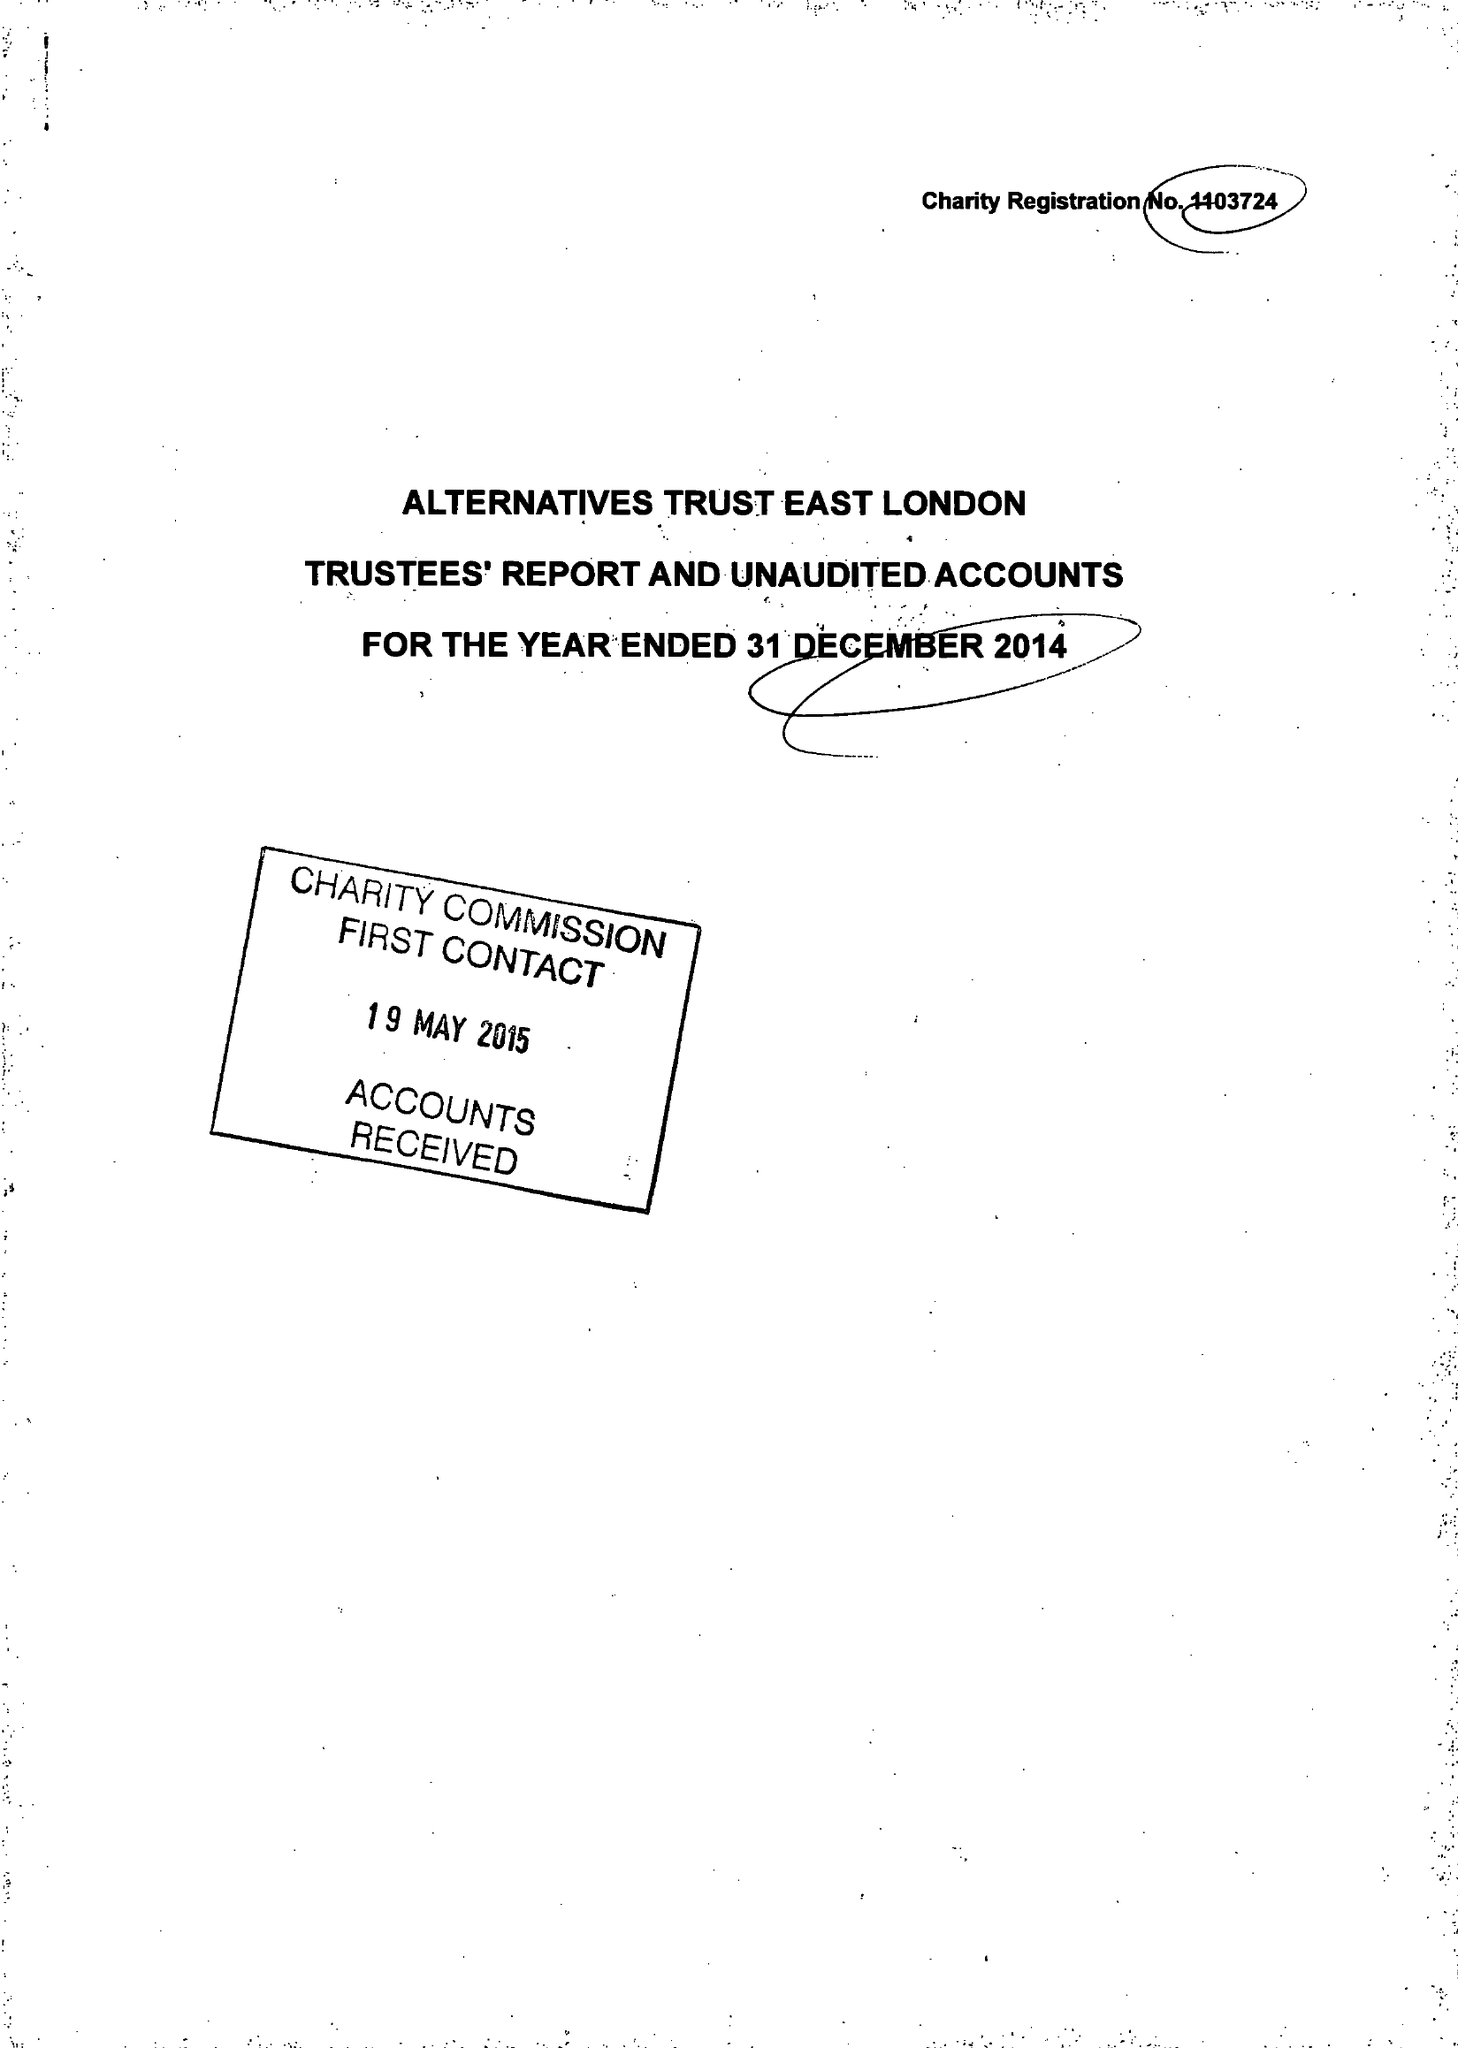What is the value for the charity_name?
Answer the question using a single word or phrase. Alternatives Trust East London 